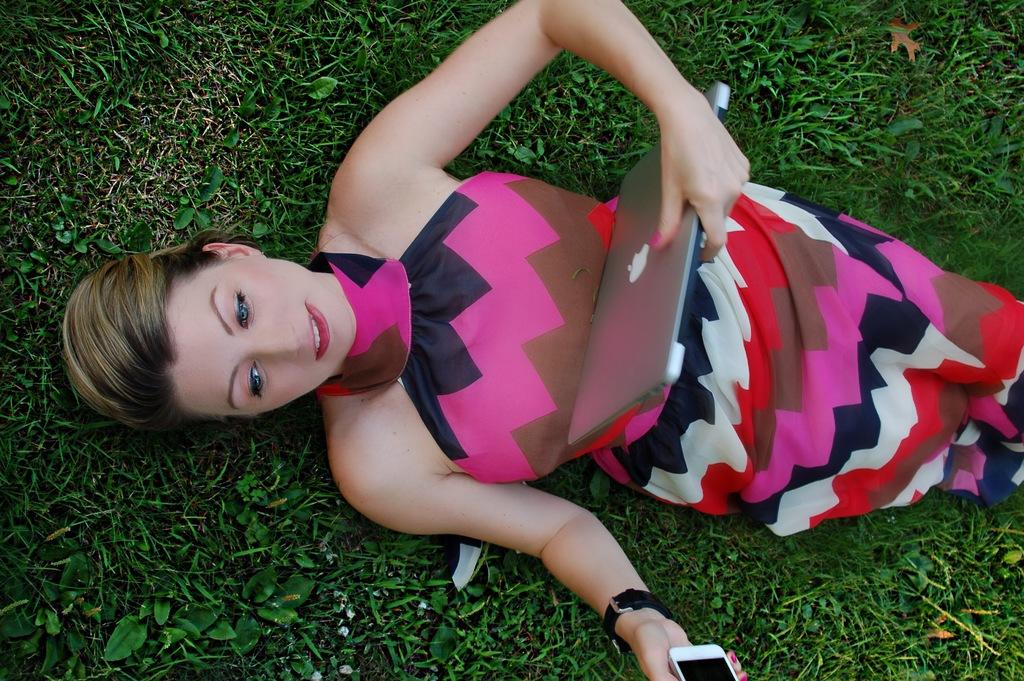What is the main subject of the image? There is a beautiful girl in the image. What is the girl doing in the image? The girl is laying on the grass. What electronic devices is the girl holding? The girl is holding a laptop and a mobile phone. What can you tell about the girl's clothing in the image? The girl is wearing a dress with pink, black, and brown colors. What type of coil is the girl using to support her laptop in the image? There is no coil present in the image; the girl is simply holding the laptop. Is the girl wearing trousers in the image? No, the girl is wearing a dress, not trousers, in the image. 